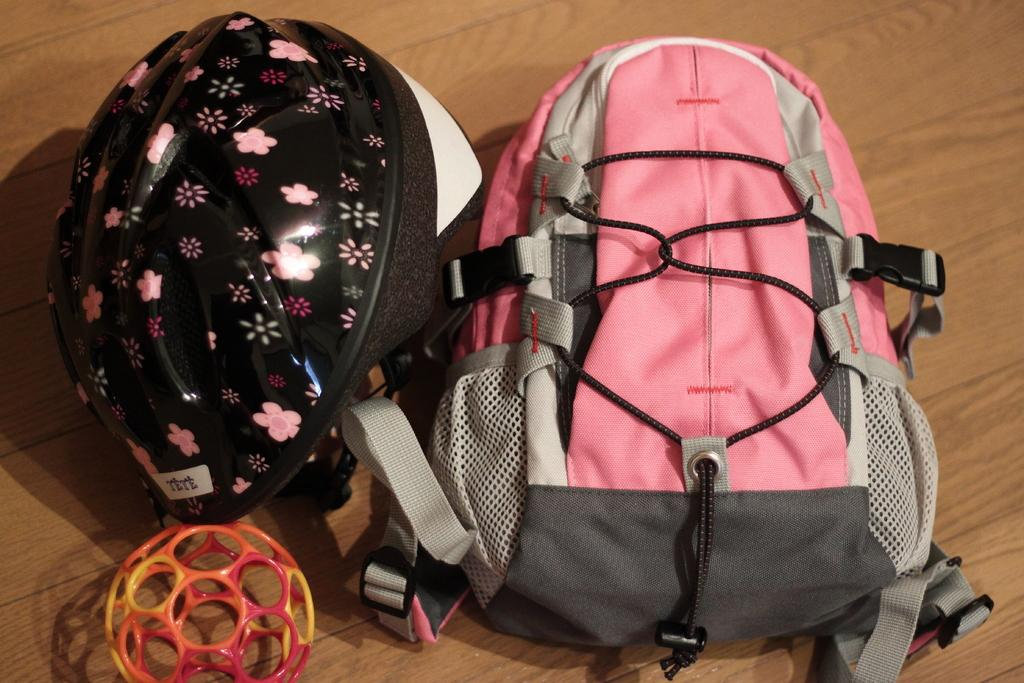What object is present in the image that might be used for carrying items? There is a bag in the image. What object is present in the image that might be used for protection? There is a helmet in the image. What type of government is depicted in the image? There is no depiction of a government in the image; it only features a bag and a helmet. What sound-making object is present in the image? There is no whistle present in the image; it only features a bag and a helmet. 